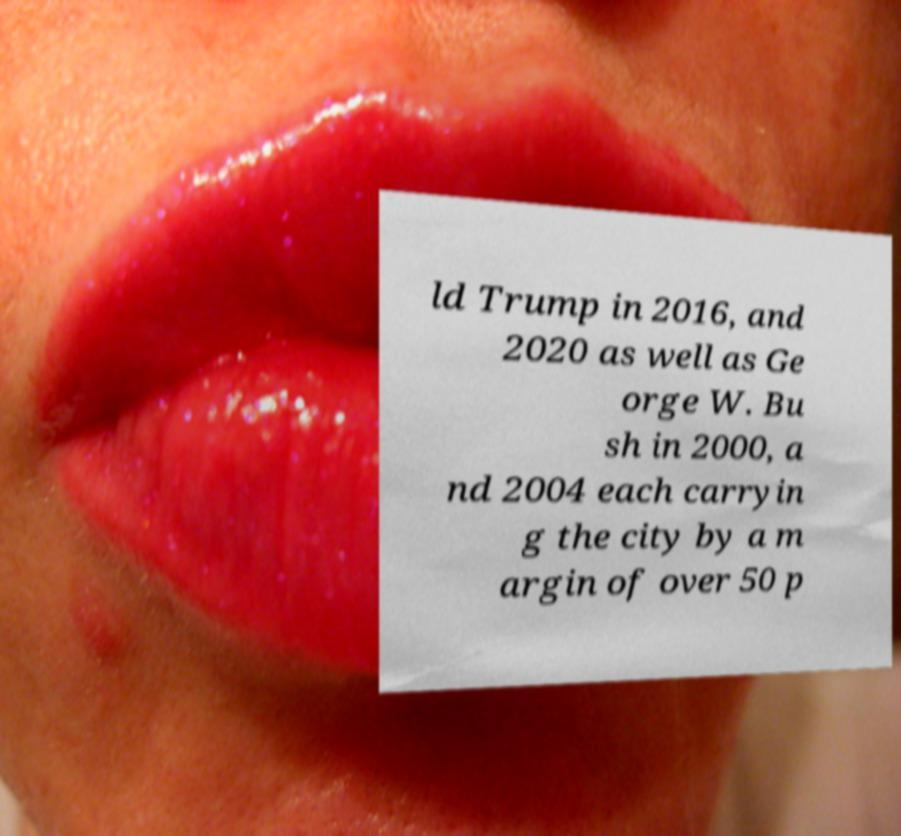I need the written content from this picture converted into text. Can you do that? ld Trump in 2016, and 2020 as well as Ge orge W. Bu sh in 2000, a nd 2004 each carryin g the city by a m argin of over 50 p 